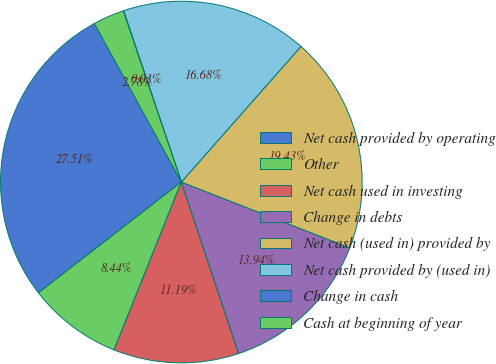Convert chart. <chart><loc_0><loc_0><loc_500><loc_500><pie_chart><fcel>Net cash provided by operating<fcel>Other<fcel>Net cash used in investing<fcel>Change in debts<fcel>Net cash (used in) provided by<fcel>Net cash provided by (used in)<fcel>Change in cash<fcel>Cash at beginning of year<nl><fcel>27.51%<fcel>8.44%<fcel>11.19%<fcel>13.94%<fcel>19.43%<fcel>16.68%<fcel>0.03%<fcel>2.78%<nl></chart> 